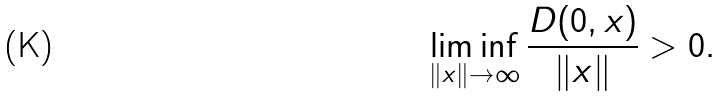Convert formula to latex. <formula><loc_0><loc_0><loc_500><loc_500>\liminf _ { \| x \| \to \infty } \frac { D ( 0 , x ) } { \| x \| } > 0 .</formula> 